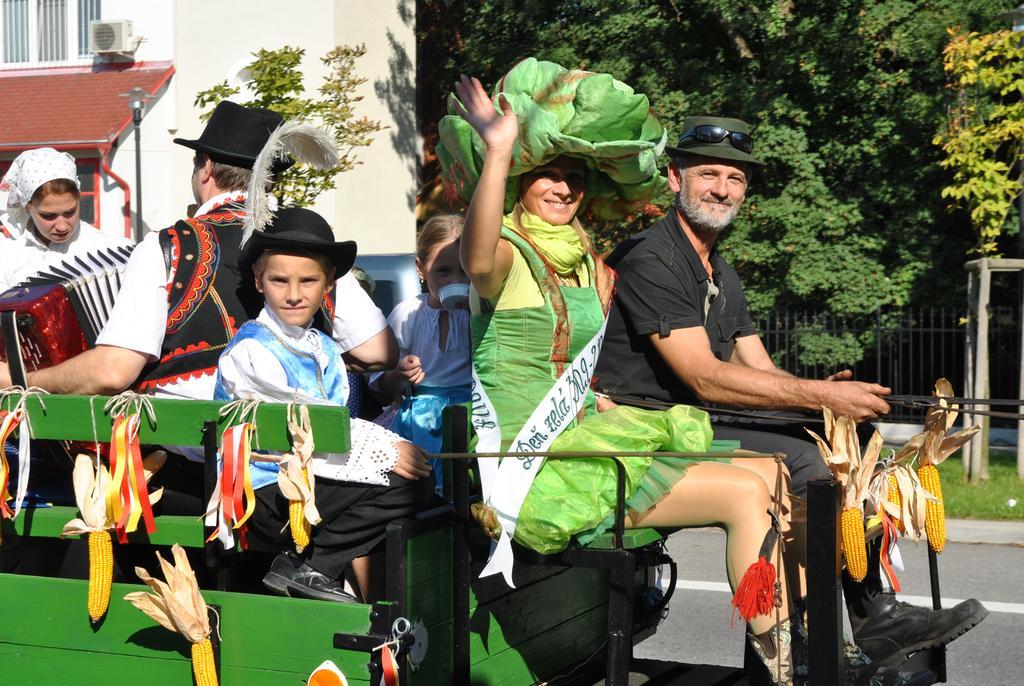Please provide a concise description of this image. In the foreground of the picture there is a vehicle, in the vehicle there are kids, men and women with different costumes. To the vehicle there are ribbons and corn. In the background there are trees, air conditioner and building. 